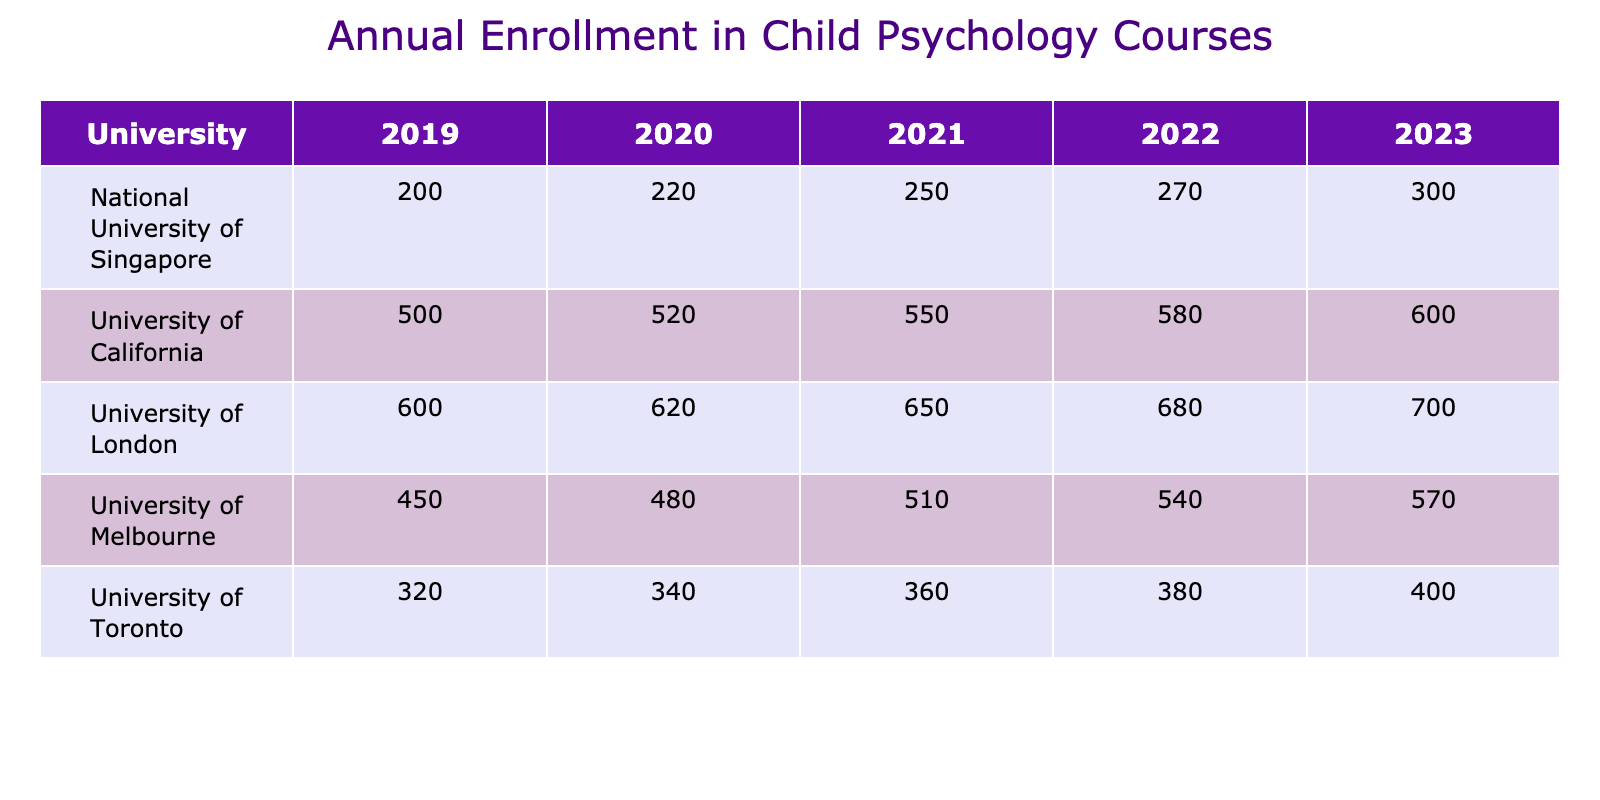What was the enrollment for the University of Melbourne in 2021? The table shows that the enrollment for the University of Melbourne in 2021 is directly listed under that year. By checking the row for the University of Melbourne, I find the enrollment value is 510.
Answer: 510 Which university had the highest enrollment in 2023? Looking across the 2023 column, I compare the enrollment values for each university. The University of London has the highest enrollment at 700.
Answer: University of London What is the total enrollment across all universities in 2022? To find the total enrollment for 2022, I add the enrollment figures from each university for that year: 580 + 380 + 540 + 680 + 270 = 2450.
Answer: 2450 Was there an increase in enrollment at the University of California from 2019 to 2023? By examining the enrollment for the University of California in both years, I see that it increased from 500 in 2019 to 600 in 2023. Thus, there was an increase.
Answer: Yes What is the average enrollment for the University of Toronto over the five years? I first add up the enrollment numbers for the University of Toronto from 2019 to 2023: 320 + 340 + 360 + 380 + 400 = 1800. There are five years, so I divide 1800 by 5, which gives me an average of 360.
Answer: 360 In which year did National University of Singapore have the lowest enrollment? By reviewing the enrollment figures for National University of Singapore from the years 2019 to 2023, I see the values are 200, 220, 250, 270, and 300. The lowest value is 200 in 2019.
Answer: 2019 How much did the enrollment in child psychology courses at the University of London increase from 2019 to 2022? For the University of London, the enrollment was 600 in 2019 and rose to 680 in 2022. The increase can be found by subtracting 600 from 680, resulting in an increase of 80.
Answer: 80 Which university saw the largest enrollment increase from 2020 to 2021? I need to compare the differences for all universities. The calculations are as follows: University of California: 550-520=30, University of Toronto: 360-340=20, University of Melbourne: 510-480=30, University of London: 650-620=30, National University of Singapore: 250-220=30. Since the highest difference is 30, there is a tie among several universities.
Answer: Multiple universities (30 increase) What trend can be observed in the enrollment for the University of Melbourne over the five years? Looking at the enrollment numbers for the University of Melbourne from 2019 (450) to 2023 (570), I note that each year shows an increase: 450, 480, 510, 540, 570. This indicates a consistent upward trend in enrollment over the years.
Answer: Increasing trend 